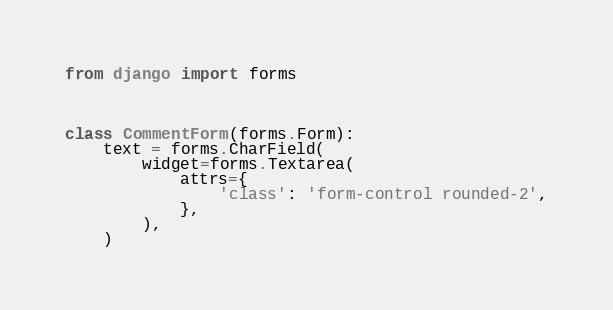Convert code to text. <code><loc_0><loc_0><loc_500><loc_500><_Python_>from django import forms



class CommentForm(forms.Form):
    text = forms.CharField(
        widget=forms.Textarea(
            attrs={
                'class': 'form-control rounded-2',
            },
        ),
    )</code> 